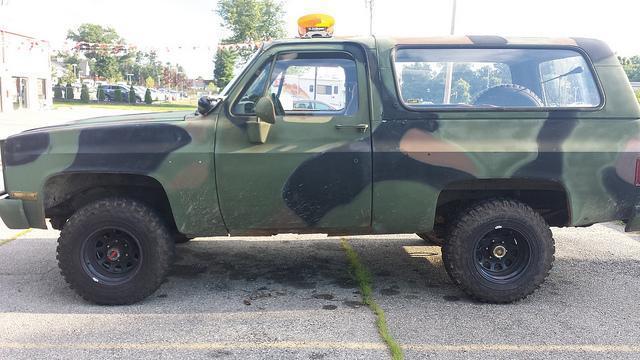How many horse eyes can you actually see?
Give a very brief answer. 0. 